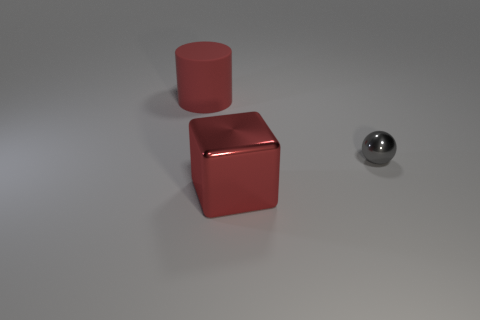Add 3 big blue matte cubes. How many objects exist? 6 Subtract all cylinders. How many objects are left? 2 Subtract 1 red cylinders. How many objects are left? 2 Subtract all big yellow metallic objects. Subtract all red matte cylinders. How many objects are left? 2 Add 2 small gray objects. How many small gray objects are left? 3 Add 2 small shiny balls. How many small shiny balls exist? 3 